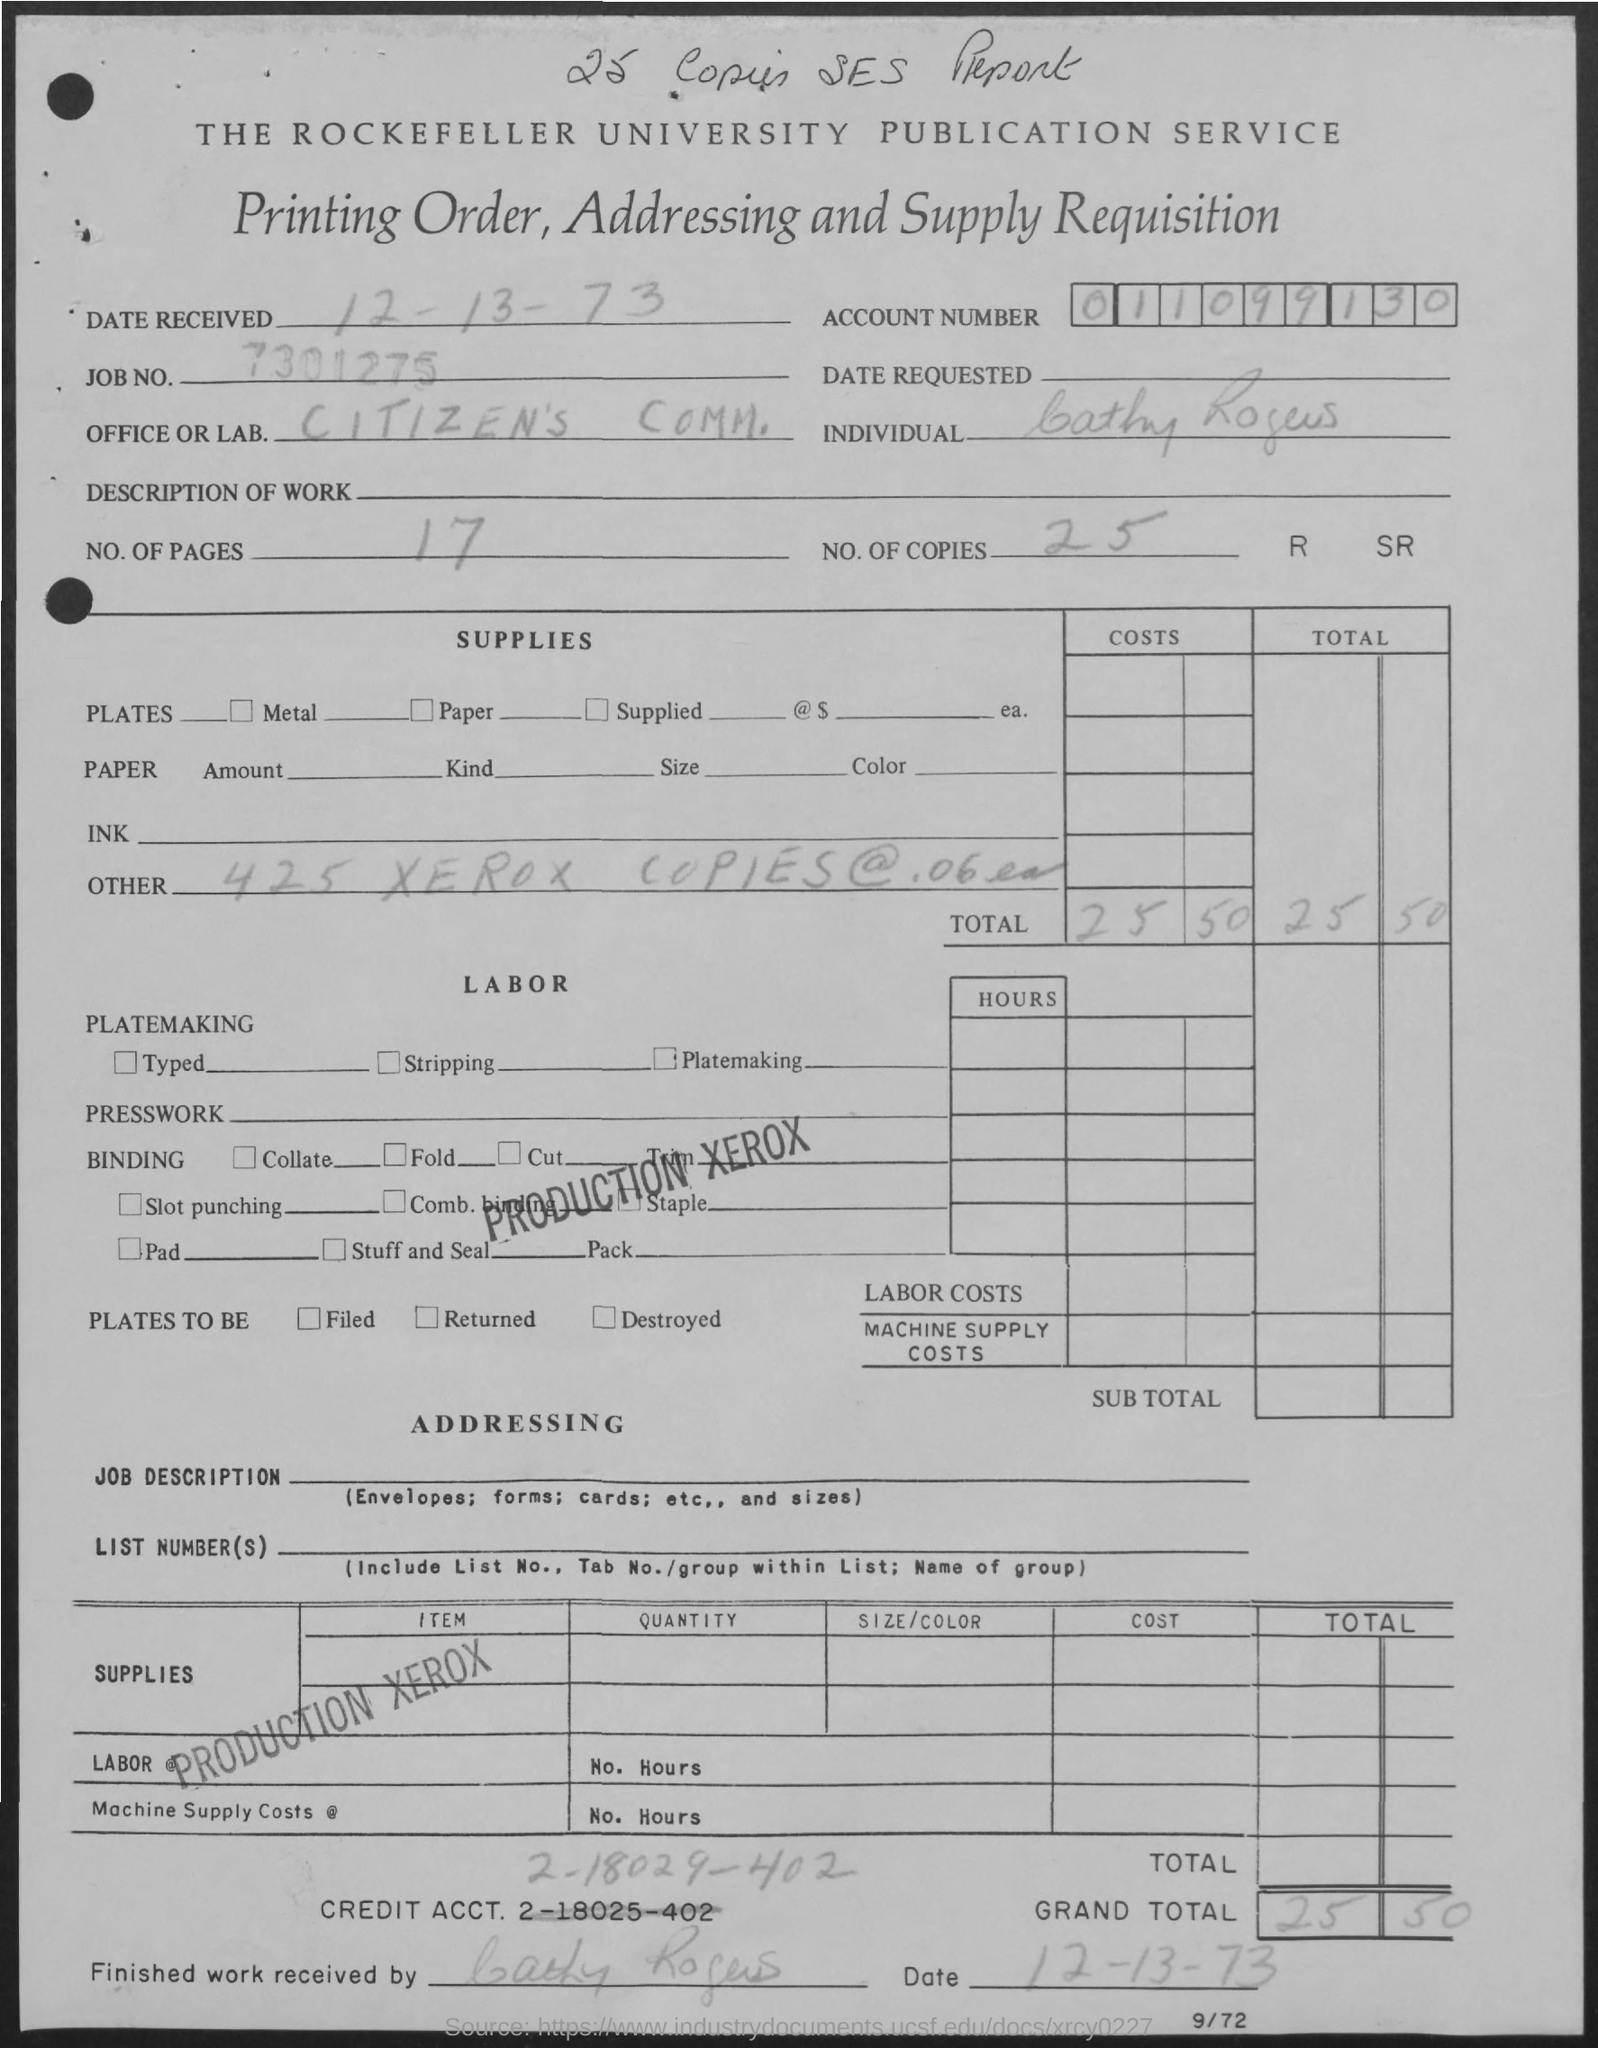How many copies are mentioned?
 25 